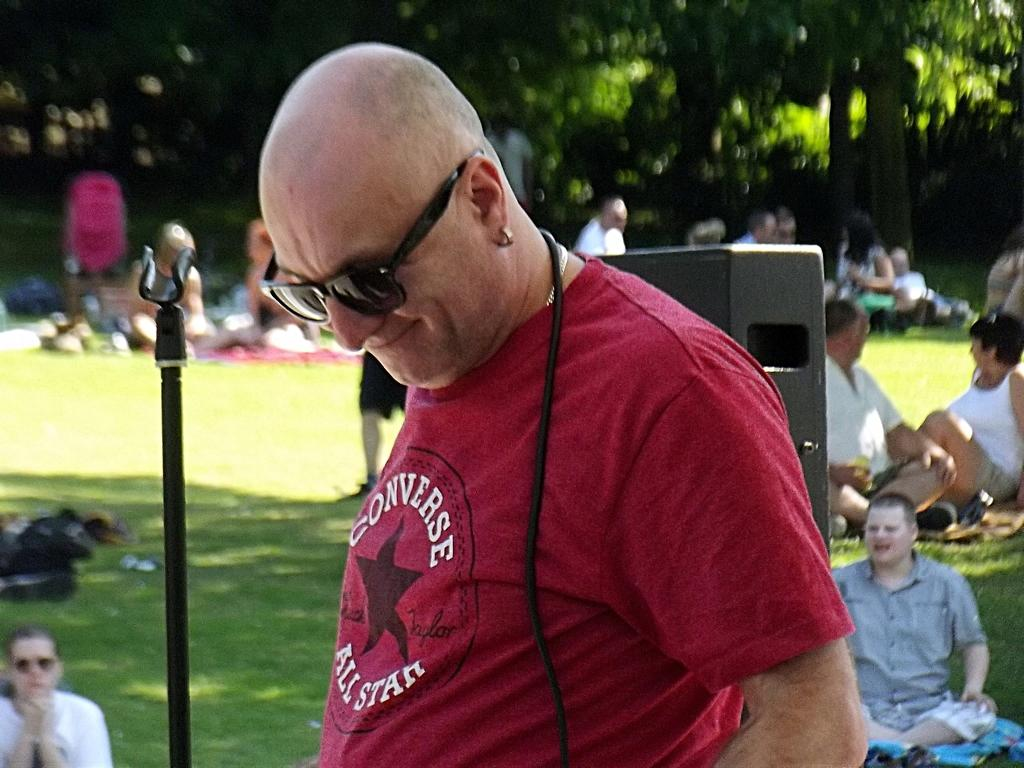What is the appearance of the man in the image? The man in the image is bald-headed and wearing a maroon t-shirt. What accessories is the man wearing in the image? The man is wearing spectacles in the image. What is the man's facial expression in the image? The man is smiling in the image. What can be seen in the background of the image? There are many people sitting on the grassland and trees visible in the background. How many ducks are sitting on the hall in the image? There are no ducks or halls present in the image. 